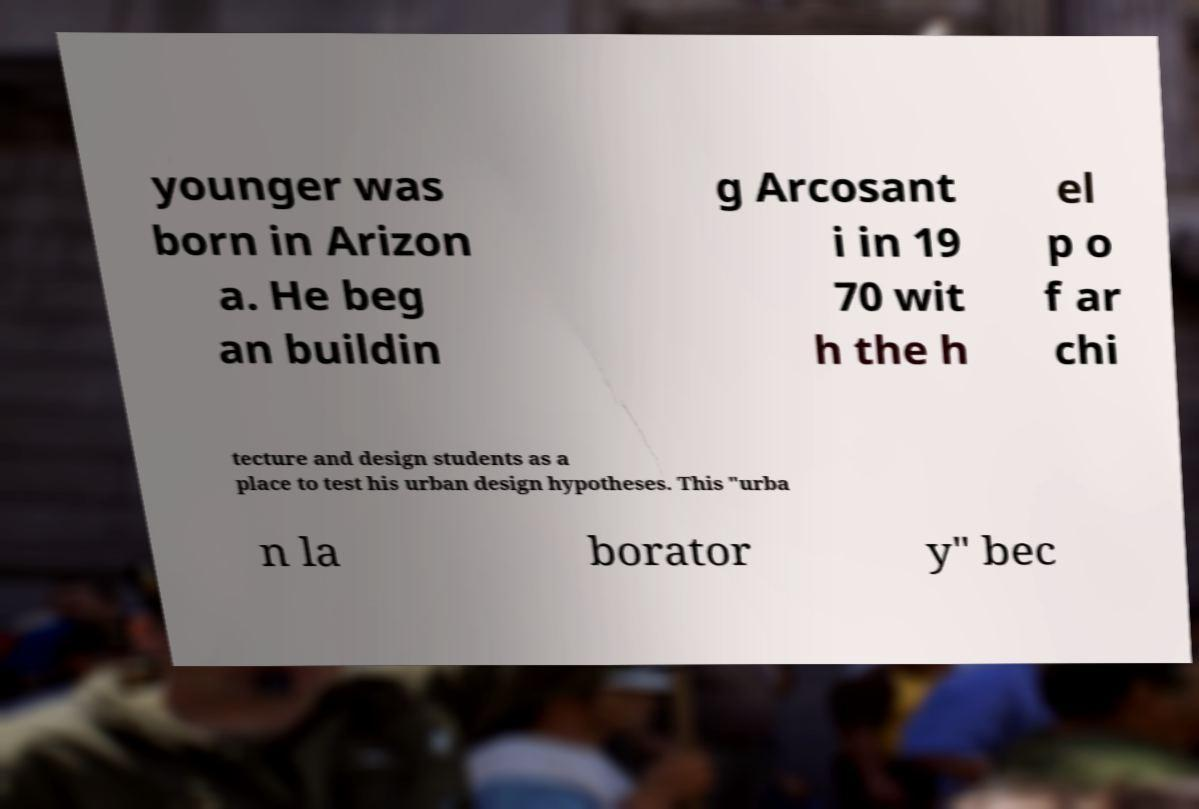For documentation purposes, I need the text within this image transcribed. Could you provide that? younger was born in Arizon a. He beg an buildin g Arcosant i in 19 70 wit h the h el p o f ar chi tecture and design students as a place to test his urban design hypotheses. This "urba n la borator y" bec 